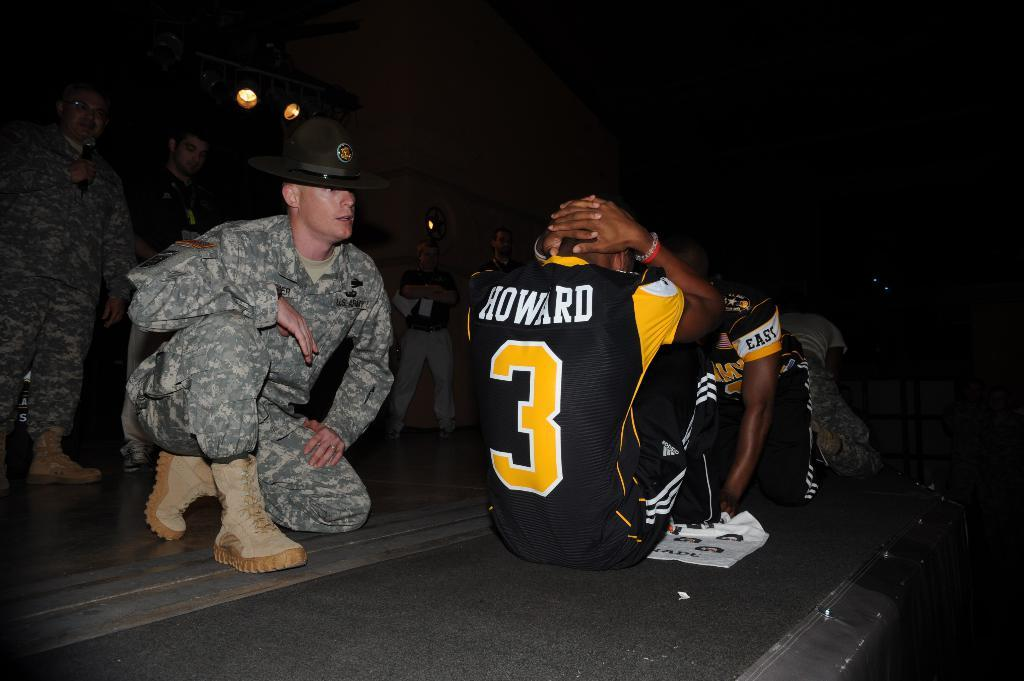<image>
Provide a brief description of the given image. A man wearing a shirt that says Howard on the back does sit ups. 